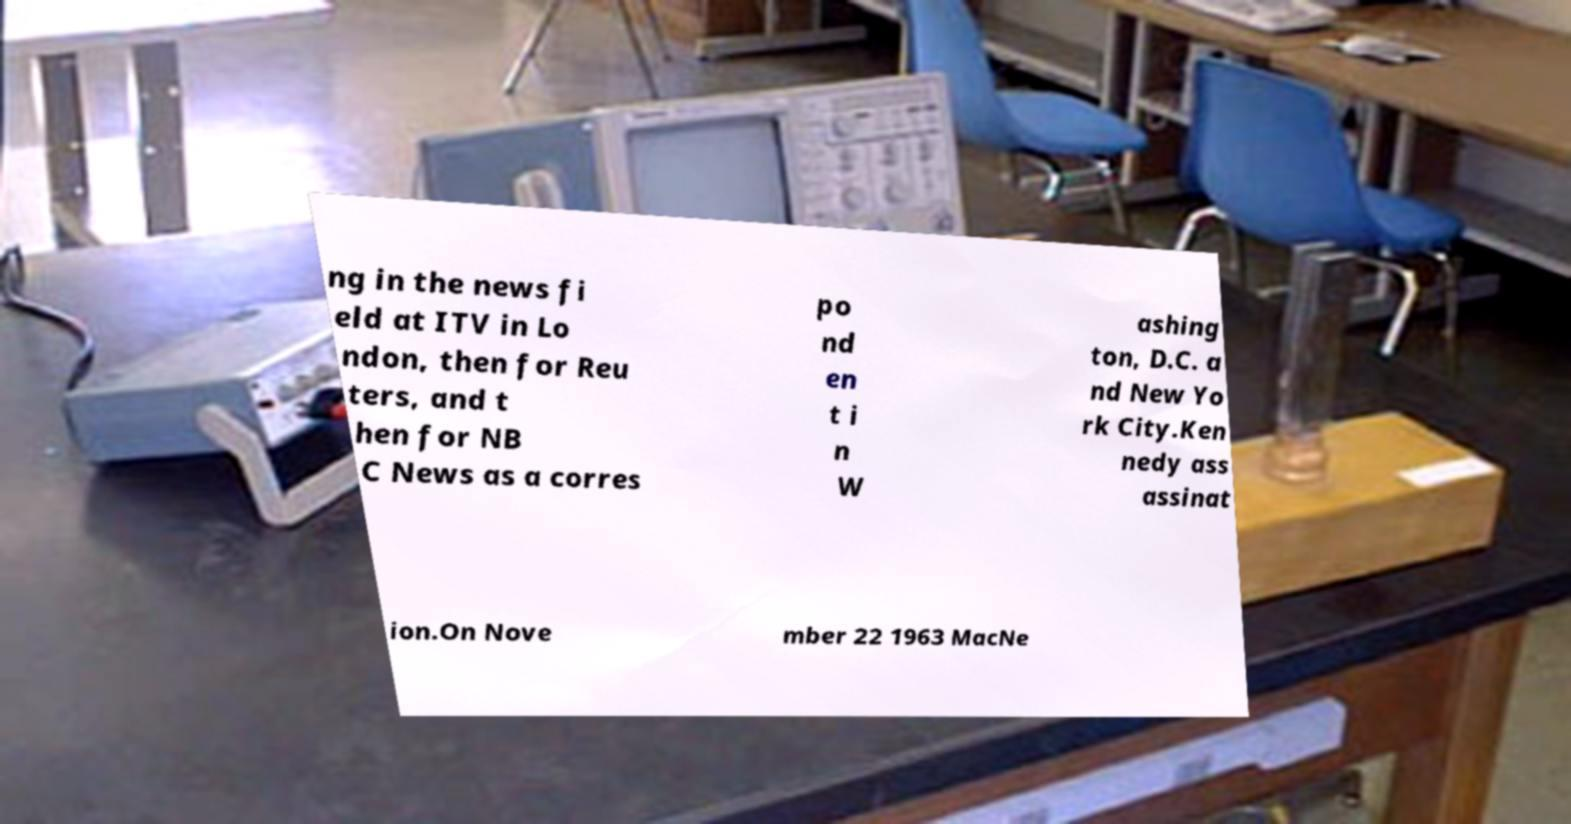Please read and relay the text visible in this image. What does it say? ng in the news fi eld at ITV in Lo ndon, then for Reu ters, and t hen for NB C News as a corres po nd en t i n W ashing ton, D.C. a nd New Yo rk City.Ken nedy ass assinat ion.On Nove mber 22 1963 MacNe 